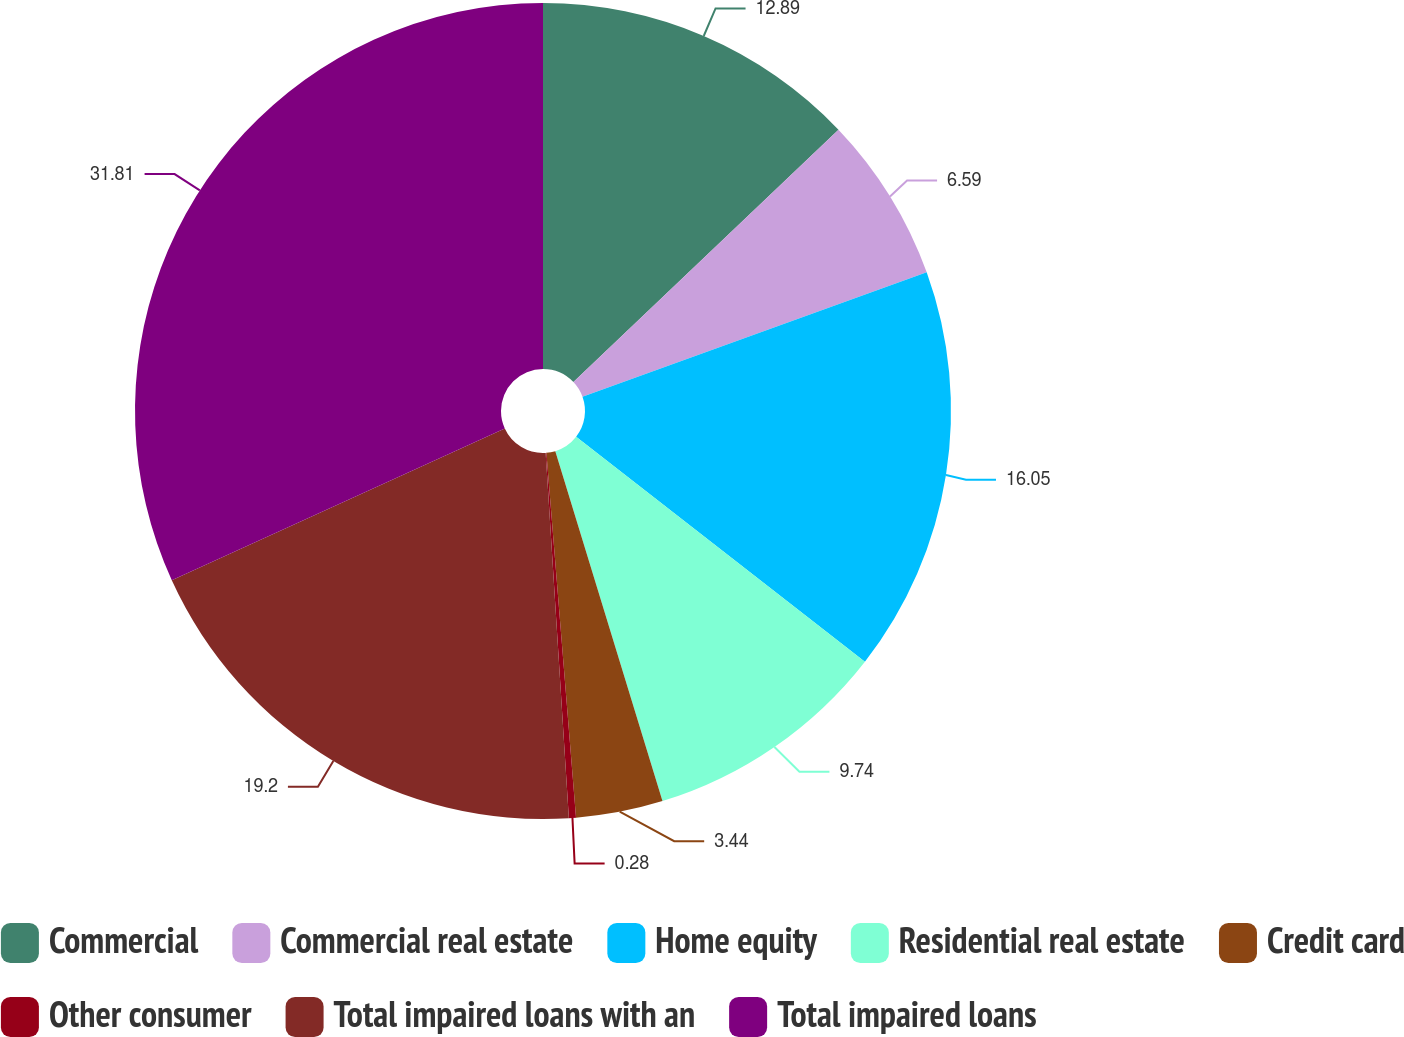Convert chart. <chart><loc_0><loc_0><loc_500><loc_500><pie_chart><fcel>Commercial<fcel>Commercial real estate<fcel>Home equity<fcel>Residential real estate<fcel>Credit card<fcel>Other consumer<fcel>Total impaired loans with an<fcel>Total impaired loans<nl><fcel>12.89%<fcel>6.59%<fcel>16.05%<fcel>9.74%<fcel>3.44%<fcel>0.28%<fcel>19.2%<fcel>31.81%<nl></chart> 